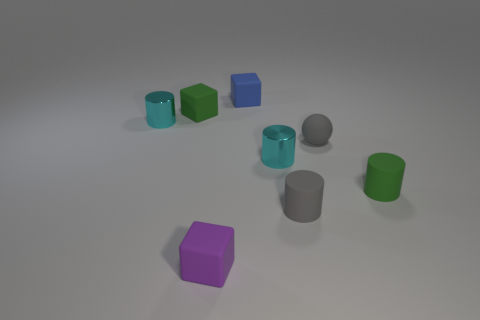Add 2 red shiny blocks. How many objects exist? 10 Subtract all blocks. How many objects are left? 5 Subtract all large cyan rubber spheres. Subtract all small gray rubber spheres. How many objects are left? 7 Add 4 green matte cylinders. How many green matte cylinders are left? 5 Add 7 cyan metallic cylinders. How many cyan metallic cylinders exist? 9 Subtract 1 green cylinders. How many objects are left? 7 